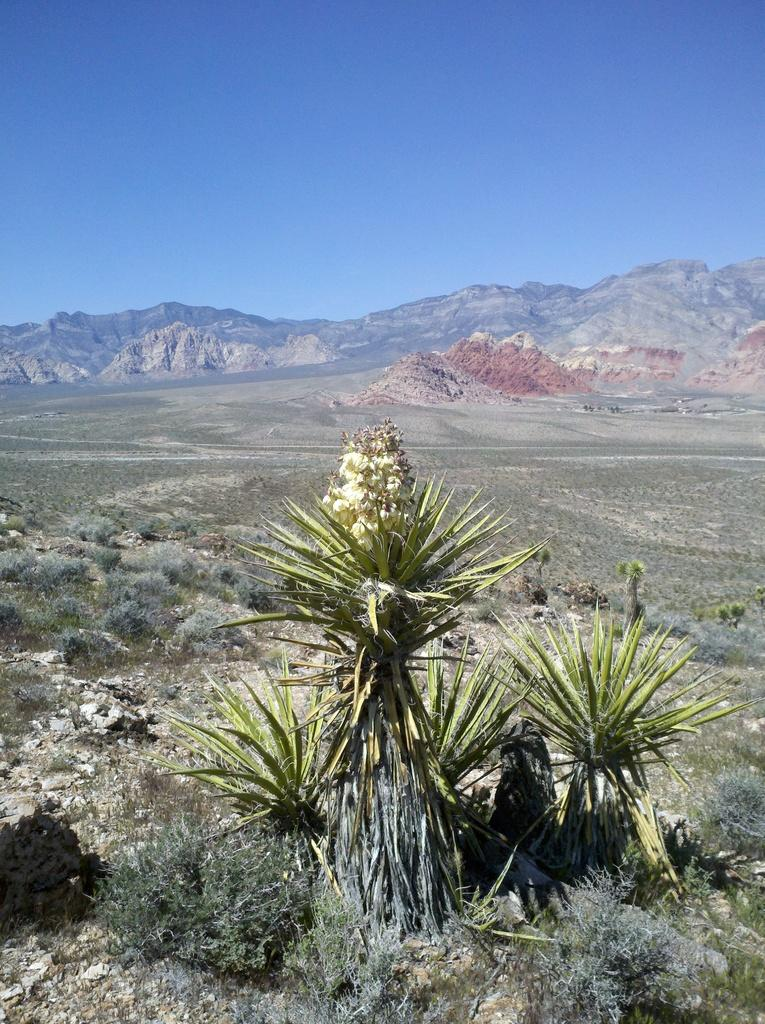What is the main subject of the image? The image depicts a mountain. What can be seen in the foreground of the image? There are plants in the foreground of the image. What other mountains can be seen in the image? There are mountains visible in the background of the image. What is visible at the top of the image? The sky is visible at the top of the image. Can you tell me how many judges are sitting on the mountain in the image? There are no judges present in the image; it features a mountain with plants in the foreground and other mountains in the background. What type of square can be seen on the mountain in the image? There is no square present on the mountain in the image. 